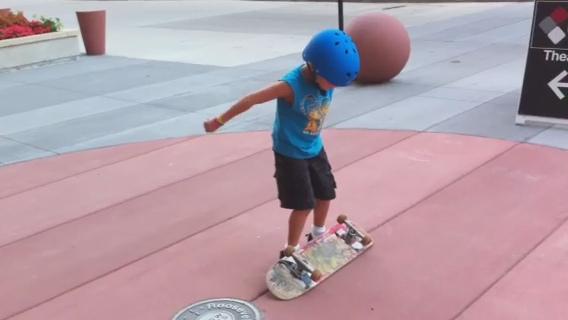What is the little boy riding?
Write a very short answer. Skateboard. What color is the boys helmet?
Short answer required. Blue. What letters can be seen on the sign?
Quick response, please. The. 